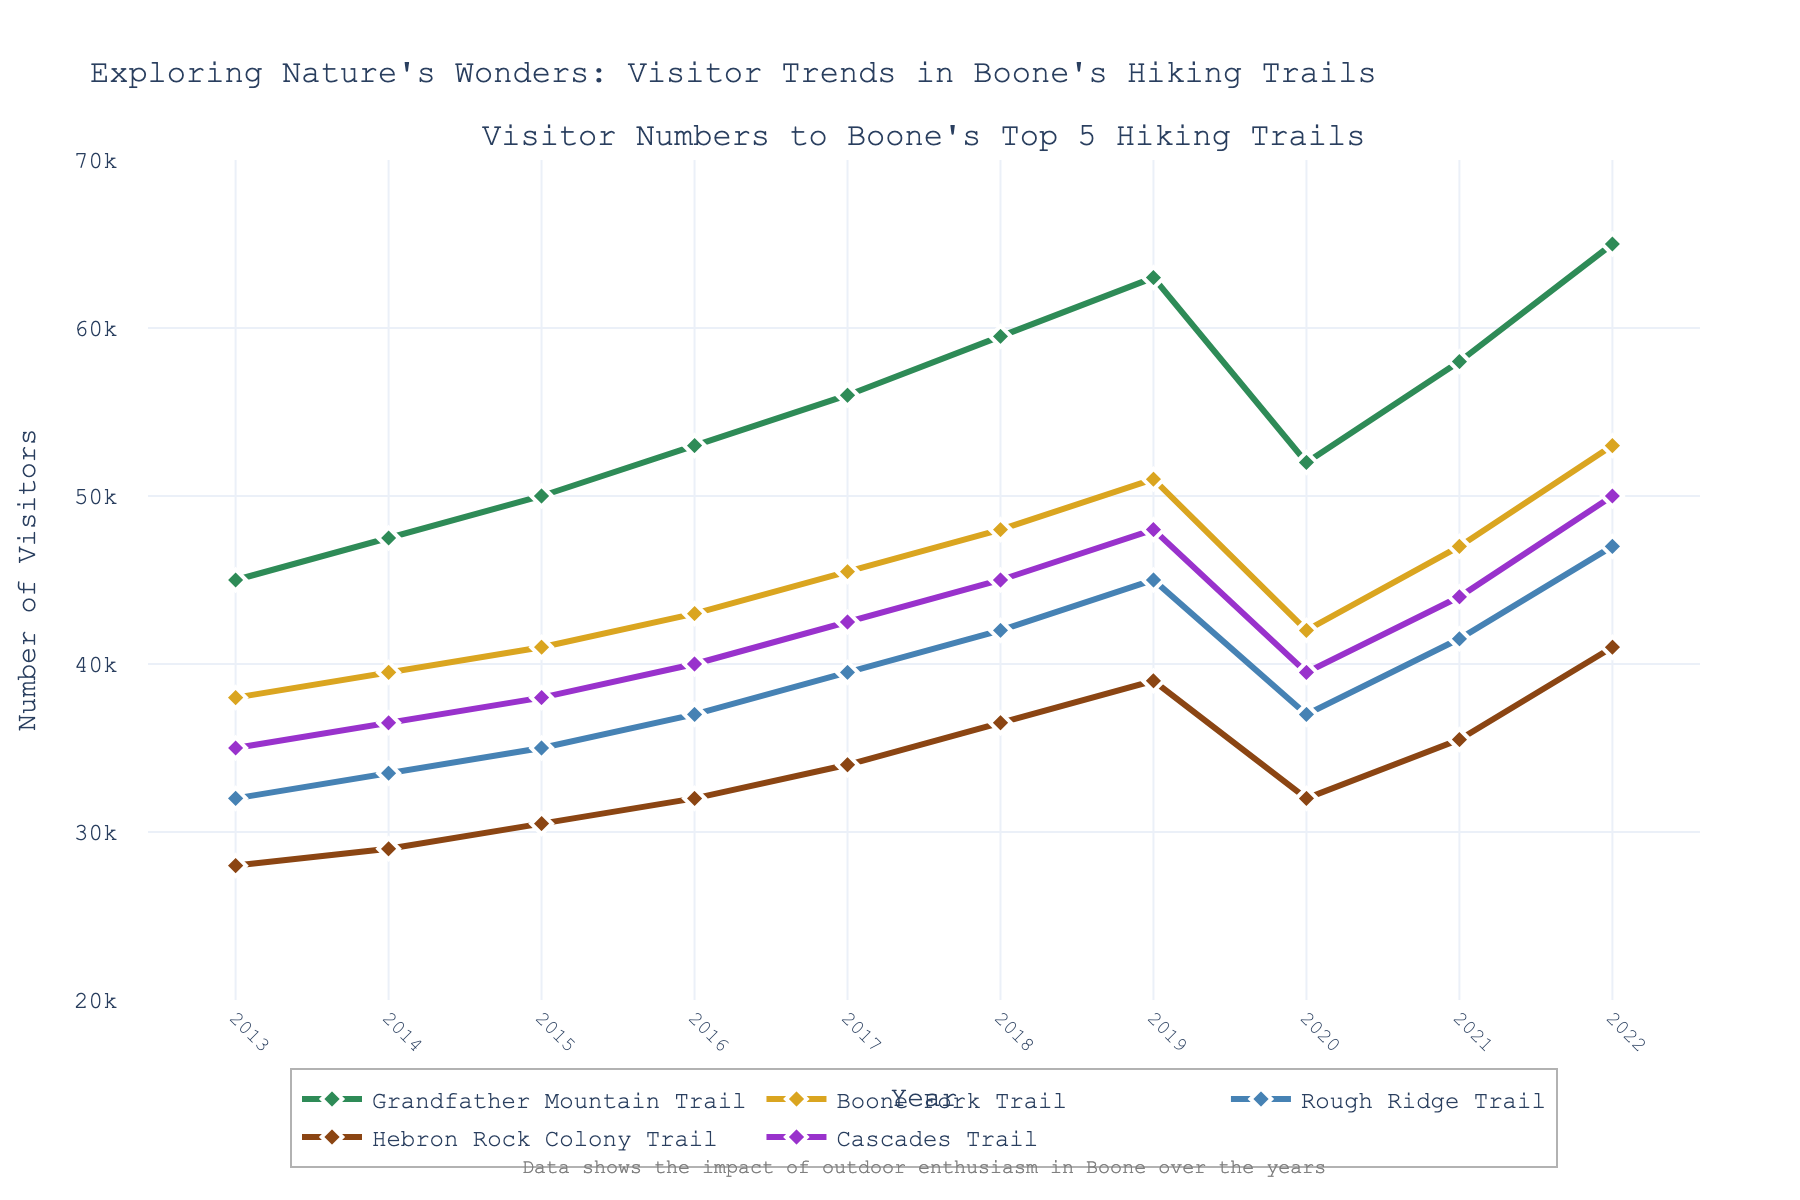What is the total number of visitors to Grandfather Mountain Trail and Rough Ridge Trail in 2022? In 2022, the number of visitors to Grandfather Mountain Trail is 65,000 and Rough Ridge Trail is 47,000. Summing these values gives 65,000 + 47,000 = 112,000
Answer: 112,000 Which trail experienced the highest number of visitors in 2019? In 2019, the number of visitors to each trail are: Grandfather Mountain Trail (63,000), Boone Fork Trail (51,000), Rough Ridge Trail (45,000), Hebron Rock Colony Trail (39,000), Cascades Trail (48,000). Grandfather Mountain Trail has the highest number of visitors.
Answer: Grandfather Mountain Trail Which year shows the lowest visitors for Cascades Trail, and what is that number? Cascades Trail has the following number of visitors over the years: 2013 (35,000), 2014 (36,500), 2015 (38,000), 2016 (40,000), 2017 (42,500), 2018 (45,000), 2019 (48,000), 2020 (39,500), 2021 (44,000), 2022 (50,000). The lowest number is in 2013 with 35,000 visitors.
Answer: 2013, 35,000 Between which two consecutive years did Boone Fork Trail see the highest increase in visitors? Calculating the increase year by year: 2013-2014 (38,000 to 39,500; +1,500), 2014-2015 (39,500 to 41,000; +1,500), 2015-2016 (41,000 to 43,000; +2,000), 2016-2017 (43,000 to 45,500; +2,500), 2017-2018 (45,500 to 48,000; +2,500), 2018-2019 (48,000 to 51,000; +3,000). The highest increase is between 2018 and 2019 (+3,000).
Answer: 2018-2019 Visualizing the trend, what is the color of the line representing Hebron Rock Colony Trail? The line representing Hebron Rock Colony Trail in the plot is visually brown.
Answer: brown How did the visitor numbers change for Grandfather Mountain Trail from 2019 to 2020? Grandfather Mountain Trail had 63,000 visitors in 2019 and 52,000 in 2020. The change is 63,000 - 52,000 = 11,000 decrease.
Answer: Decreased by 11,000 Around how many visitors did Rough Ridge Trail have in 2017? The number of visitors to Rough Ridge Trail in 2017 was approximately 39,500.
Answer: 39,500 What is the average number of visitors to Cascade Trail over the past decade? Sum of visitors to Cascade Trail over the years is 35,000 + 36,500 + 38,000 + 40,000 + 42,500 + 45,000 + 48,000 + 39,500 + 44,000 + 50,000 = 418,500. There are 10 years, so the average is 418,500 / 10 = 41,850
Answer: 41,850 Which trail shows the most significant drop in visitors from 2019 to 2020? The visitors for each trail from 2019 to 2020 are: Grandfather Mountain Trail (63,000 to 52,000; -11,000), Boone Fork Trail (51,000 to 42,000; -9,000), Rough Ridge Trail (45,000 to 37,000; -8,000), Hebron Rock Colony Trail (39,000 to 32,000; -7,000), Cascades Trail (48,000 to 39,500; -8,500). The most significant drop is for Grandfather Mountain Trail (-11,000).
Answer: Grandfather Mountain Trail 